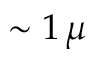Convert formula to latex. <formula><loc_0><loc_0><loc_500><loc_500>\sim 1 \, \mu</formula> 